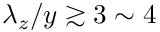Convert formula to latex. <formula><loc_0><loc_0><loc_500><loc_500>\lambda _ { z } / y \gtrsim 3 \sim 4</formula> 